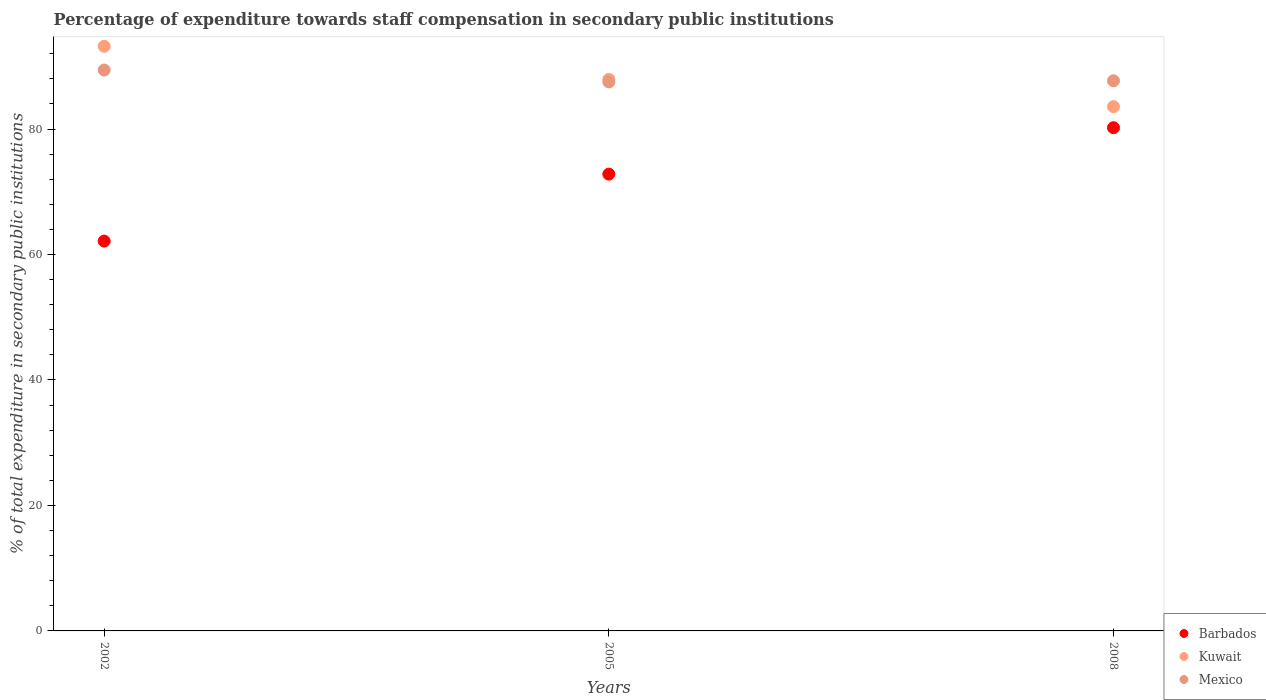How many different coloured dotlines are there?
Offer a terse response. 3. Is the number of dotlines equal to the number of legend labels?
Offer a terse response. Yes. What is the percentage of expenditure towards staff compensation in Barbados in 2005?
Ensure brevity in your answer.  72.82. Across all years, what is the maximum percentage of expenditure towards staff compensation in Kuwait?
Keep it short and to the point. 93.19. Across all years, what is the minimum percentage of expenditure towards staff compensation in Barbados?
Your answer should be compact. 62.14. In which year was the percentage of expenditure towards staff compensation in Kuwait minimum?
Offer a terse response. 2008. What is the total percentage of expenditure towards staff compensation in Mexico in the graph?
Provide a short and direct response. 264.63. What is the difference between the percentage of expenditure towards staff compensation in Barbados in 2002 and that in 2008?
Offer a very short reply. -18.07. What is the difference between the percentage of expenditure towards staff compensation in Mexico in 2002 and the percentage of expenditure towards staff compensation in Kuwait in 2005?
Keep it short and to the point. 1.48. What is the average percentage of expenditure towards staff compensation in Barbados per year?
Offer a very short reply. 71.73. In the year 2005, what is the difference between the percentage of expenditure towards staff compensation in Mexico and percentage of expenditure towards staff compensation in Kuwait?
Offer a very short reply. -0.41. What is the ratio of the percentage of expenditure towards staff compensation in Barbados in 2002 to that in 2008?
Your answer should be very brief. 0.77. Is the difference between the percentage of expenditure towards staff compensation in Mexico in 2005 and 2008 greater than the difference between the percentage of expenditure towards staff compensation in Kuwait in 2005 and 2008?
Give a very brief answer. No. What is the difference between the highest and the second highest percentage of expenditure towards staff compensation in Barbados?
Offer a very short reply. 7.4. What is the difference between the highest and the lowest percentage of expenditure towards staff compensation in Mexico?
Make the answer very short. 1.89. Is it the case that in every year, the sum of the percentage of expenditure towards staff compensation in Mexico and percentage of expenditure towards staff compensation in Kuwait  is greater than the percentage of expenditure towards staff compensation in Barbados?
Give a very brief answer. Yes. Does the percentage of expenditure towards staff compensation in Mexico monotonically increase over the years?
Your response must be concise. No. Is the percentage of expenditure towards staff compensation in Kuwait strictly less than the percentage of expenditure towards staff compensation in Mexico over the years?
Give a very brief answer. No. Are the values on the major ticks of Y-axis written in scientific E-notation?
Provide a short and direct response. No. Does the graph contain any zero values?
Give a very brief answer. No. Does the graph contain grids?
Ensure brevity in your answer.  No. Where does the legend appear in the graph?
Your answer should be very brief. Bottom right. How are the legend labels stacked?
Ensure brevity in your answer.  Vertical. What is the title of the graph?
Offer a terse response. Percentage of expenditure towards staff compensation in secondary public institutions. What is the label or title of the Y-axis?
Give a very brief answer. % of total expenditure in secondary public institutions. What is the % of total expenditure in secondary public institutions of Barbados in 2002?
Make the answer very short. 62.14. What is the % of total expenditure in secondary public institutions in Kuwait in 2002?
Your response must be concise. 93.19. What is the % of total expenditure in secondary public institutions in Mexico in 2002?
Your answer should be very brief. 89.41. What is the % of total expenditure in secondary public institutions in Barbados in 2005?
Your answer should be compact. 72.82. What is the % of total expenditure in secondary public institutions of Kuwait in 2005?
Keep it short and to the point. 87.93. What is the % of total expenditure in secondary public institutions of Mexico in 2005?
Provide a short and direct response. 87.52. What is the % of total expenditure in secondary public institutions in Barbados in 2008?
Offer a terse response. 80.22. What is the % of total expenditure in secondary public institutions of Kuwait in 2008?
Make the answer very short. 83.57. What is the % of total expenditure in secondary public institutions in Mexico in 2008?
Provide a short and direct response. 87.7. Across all years, what is the maximum % of total expenditure in secondary public institutions of Barbados?
Offer a very short reply. 80.22. Across all years, what is the maximum % of total expenditure in secondary public institutions of Kuwait?
Your answer should be very brief. 93.19. Across all years, what is the maximum % of total expenditure in secondary public institutions of Mexico?
Keep it short and to the point. 89.41. Across all years, what is the minimum % of total expenditure in secondary public institutions in Barbados?
Offer a very short reply. 62.14. Across all years, what is the minimum % of total expenditure in secondary public institutions in Kuwait?
Give a very brief answer. 83.57. Across all years, what is the minimum % of total expenditure in secondary public institutions in Mexico?
Your answer should be compact. 87.52. What is the total % of total expenditure in secondary public institutions in Barbados in the graph?
Make the answer very short. 215.18. What is the total % of total expenditure in secondary public institutions in Kuwait in the graph?
Offer a very short reply. 264.69. What is the total % of total expenditure in secondary public institutions in Mexico in the graph?
Your response must be concise. 264.63. What is the difference between the % of total expenditure in secondary public institutions in Barbados in 2002 and that in 2005?
Give a very brief answer. -10.68. What is the difference between the % of total expenditure in secondary public institutions in Kuwait in 2002 and that in 2005?
Your answer should be very brief. 5.26. What is the difference between the % of total expenditure in secondary public institutions in Mexico in 2002 and that in 2005?
Keep it short and to the point. 1.89. What is the difference between the % of total expenditure in secondary public institutions of Barbados in 2002 and that in 2008?
Make the answer very short. -18.07. What is the difference between the % of total expenditure in secondary public institutions in Kuwait in 2002 and that in 2008?
Your answer should be compact. 9.62. What is the difference between the % of total expenditure in secondary public institutions of Mexico in 2002 and that in 2008?
Make the answer very short. 1.71. What is the difference between the % of total expenditure in secondary public institutions of Barbados in 2005 and that in 2008?
Give a very brief answer. -7.4. What is the difference between the % of total expenditure in secondary public institutions in Kuwait in 2005 and that in 2008?
Make the answer very short. 4.36. What is the difference between the % of total expenditure in secondary public institutions of Mexico in 2005 and that in 2008?
Ensure brevity in your answer.  -0.18. What is the difference between the % of total expenditure in secondary public institutions in Barbados in 2002 and the % of total expenditure in secondary public institutions in Kuwait in 2005?
Provide a short and direct response. -25.79. What is the difference between the % of total expenditure in secondary public institutions of Barbados in 2002 and the % of total expenditure in secondary public institutions of Mexico in 2005?
Your answer should be compact. -25.37. What is the difference between the % of total expenditure in secondary public institutions of Kuwait in 2002 and the % of total expenditure in secondary public institutions of Mexico in 2005?
Offer a very short reply. 5.68. What is the difference between the % of total expenditure in secondary public institutions of Barbados in 2002 and the % of total expenditure in secondary public institutions of Kuwait in 2008?
Your answer should be compact. -21.43. What is the difference between the % of total expenditure in secondary public institutions of Barbados in 2002 and the % of total expenditure in secondary public institutions of Mexico in 2008?
Give a very brief answer. -25.56. What is the difference between the % of total expenditure in secondary public institutions of Kuwait in 2002 and the % of total expenditure in secondary public institutions of Mexico in 2008?
Offer a very short reply. 5.49. What is the difference between the % of total expenditure in secondary public institutions of Barbados in 2005 and the % of total expenditure in secondary public institutions of Kuwait in 2008?
Make the answer very short. -10.75. What is the difference between the % of total expenditure in secondary public institutions in Barbados in 2005 and the % of total expenditure in secondary public institutions in Mexico in 2008?
Provide a short and direct response. -14.88. What is the difference between the % of total expenditure in secondary public institutions in Kuwait in 2005 and the % of total expenditure in secondary public institutions in Mexico in 2008?
Ensure brevity in your answer.  0.23. What is the average % of total expenditure in secondary public institutions of Barbados per year?
Offer a terse response. 71.73. What is the average % of total expenditure in secondary public institutions in Kuwait per year?
Make the answer very short. 88.23. What is the average % of total expenditure in secondary public institutions in Mexico per year?
Provide a succinct answer. 88.21. In the year 2002, what is the difference between the % of total expenditure in secondary public institutions in Barbados and % of total expenditure in secondary public institutions in Kuwait?
Give a very brief answer. -31.05. In the year 2002, what is the difference between the % of total expenditure in secondary public institutions in Barbados and % of total expenditure in secondary public institutions in Mexico?
Ensure brevity in your answer.  -27.27. In the year 2002, what is the difference between the % of total expenditure in secondary public institutions of Kuwait and % of total expenditure in secondary public institutions of Mexico?
Make the answer very short. 3.78. In the year 2005, what is the difference between the % of total expenditure in secondary public institutions of Barbados and % of total expenditure in secondary public institutions of Kuwait?
Provide a short and direct response. -15.11. In the year 2005, what is the difference between the % of total expenditure in secondary public institutions in Barbados and % of total expenditure in secondary public institutions in Mexico?
Your answer should be very brief. -14.7. In the year 2005, what is the difference between the % of total expenditure in secondary public institutions of Kuwait and % of total expenditure in secondary public institutions of Mexico?
Make the answer very short. 0.41. In the year 2008, what is the difference between the % of total expenditure in secondary public institutions of Barbados and % of total expenditure in secondary public institutions of Kuwait?
Your answer should be compact. -3.36. In the year 2008, what is the difference between the % of total expenditure in secondary public institutions of Barbados and % of total expenditure in secondary public institutions of Mexico?
Keep it short and to the point. -7.48. In the year 2008, what is the difference between the % of total expenditure in secondary public institutions in Kuwait and % of total expenditure in secondary public institutions in Mexico?
Make the answer very short. -4.13. What is the ratio of the % of total expenditure in secondary public institutions in Barbados in 2002 to that in 2005?
Keep it short and to the point. 0.85. What is the ratio of the % of total expenditure in secondary public institutions of Kuwait in 2002 to that in 2005?
Provide a short and direct response. 1.06. What is the ratio of the % of total expenditure in secondary public institutions in Mexico in 2002 to that in 2005?
Ensure brevity in your answer.  1.02. What is the ratio of the % of total expenditure in secondary public institutions in Barbados in 2002 to that in 2008?
Give a very brief answer. 0.77. What is the ratio of the % of total expenditure in secondary public institutions in Kuwait in 2002 to that in 2008?
Ensure brevity in your answer.  1.12. What is the ratio of the % of total expenditure in secondary public institutions in Mexico in 2002 to that in 2008?
Offer a terse response. 1.02. What is the ratio of the % of total expenditure in secondary public institutions of Barbados in 2005 to that in 2008?
Provide a succinct answer. 0.91. What is the ratio of the % of total expenditure in secondary public institutions of Kuwait in 2005 to that in 2008?
Provide a succinct answer. 1.05. What is the ratio of the % of total expenditure in secondary public institutions of Mexico in 2005 to that in 2008?
Provide a succinct answer. 1. What is the difference between the highest and the second highest % of total expenditure in secondary public institutions in Barbados?
Your answer should be compact. 7.4. What is the difference between the highest and the second highest % of total expenditure in secondary public institutions of Kuwait?
Your answer should be very brief. 5.26. What is the difference between the highest and the second highest % of total expenditure in secondary public institutions of Mexico?
Make the answer very short. 1.71. What is the difference between the highest and the lowest % of total expenditure in secondary public institutions of Barbados?
Offer a terse response. 18.07. What is the difference between the highest and the lowest % of total expenditure in secondary public institutions in Kuwait?
Provide a short and direct response. 9.62. What is the difference between the highest and the lowest % of total expenditure in secondary public institutions of Mexico?
Offer a terse response. 1.89. 